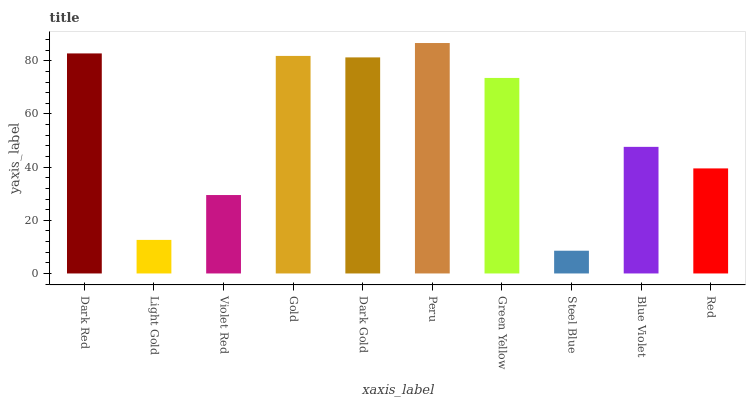Is Steel Blue the minimum?
Answer yes or no. Yes. Is Peru the maximum?
Answer yes or no. Yes. Is Light Gold the minimum?
Answer yes or no. No. Is Light Gold the maximum?
Answer yes or no. No. Is Dark Red greater than Light Gold?
Answer yes or no. Yes. Is Light Gold less than Dark Red?
Answer yes or no. Yes. Is Light Gold greater than Dark Red?
Answer yes or no. No. Is Dark Red less than Light Gold?
Answer yes or no. No. Is Green Yellow the high median?
Answer yes or no. Yes. Is Blue Violet the low median?
Answer yes or no. Yes. Is Dark Gold the high median?
Answer yes or no. No. Is Gold the low median?
Answer yes or no. No. 